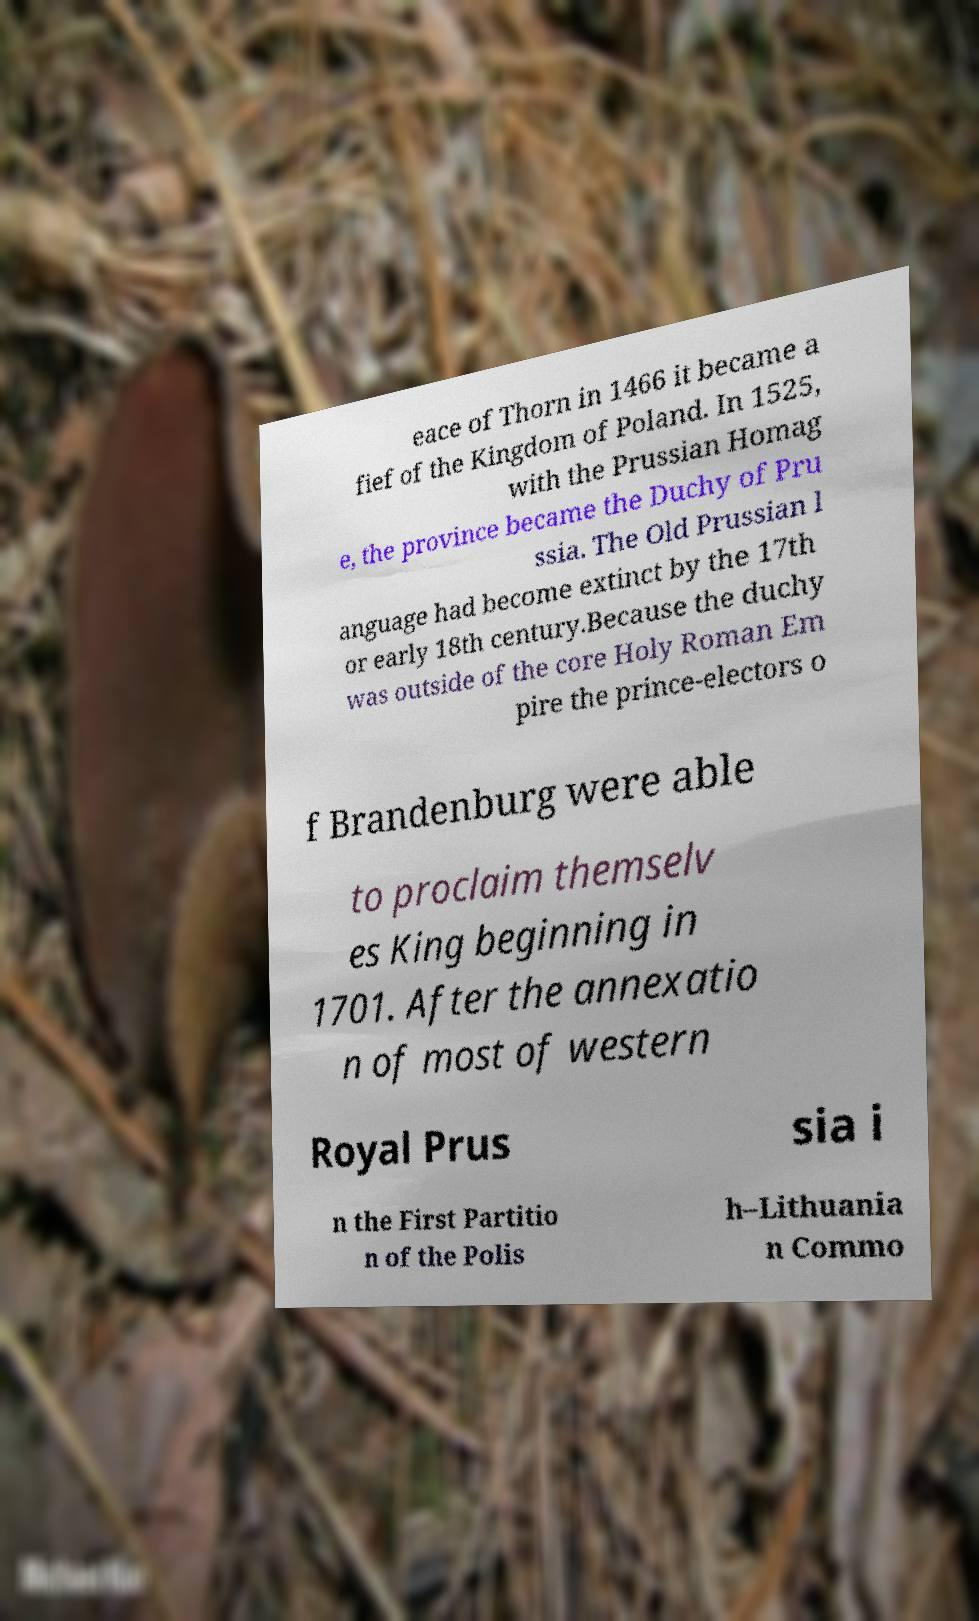Can you read and provide the text displayed in the image?This photo seems to have some interesting text. Can you extract and type it out for me? eace of Thorn in 1466 it became a fief of the Kingdom of Poland. In 1525, with the Prussian Homag e, the province became the Duchy of Pru ssia. The Old Prussian l anguage had become extinct by the 17th or early 18th century.Because the duchy was outside of the core Holy Roman Em pire the prince-electors o f Brandenburg were able to proclaim themselv es King beginning in 1701. After the annexatio n of most of western Royal Prus sia i n the First Partitio n of the Polis h–Lithuania n Commo 